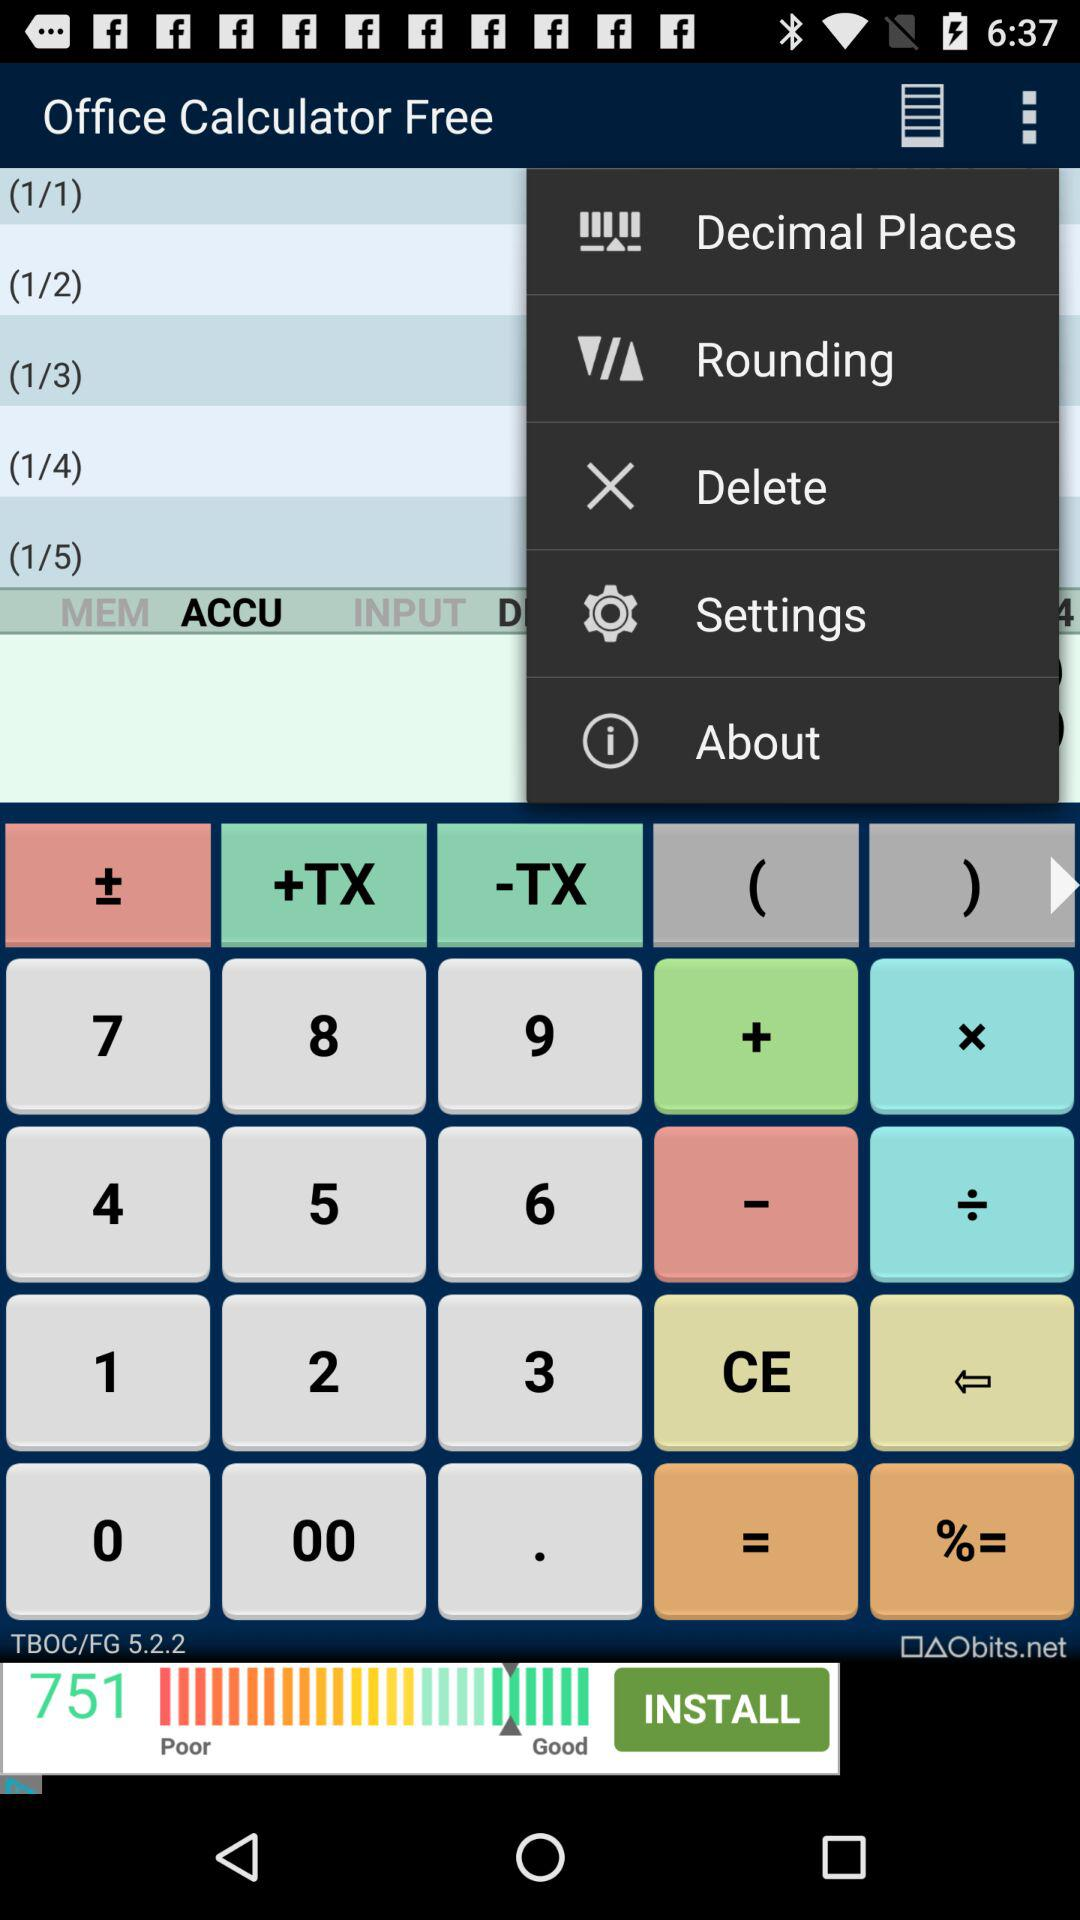What is the application name? The application name is "Office Calculator Free". 